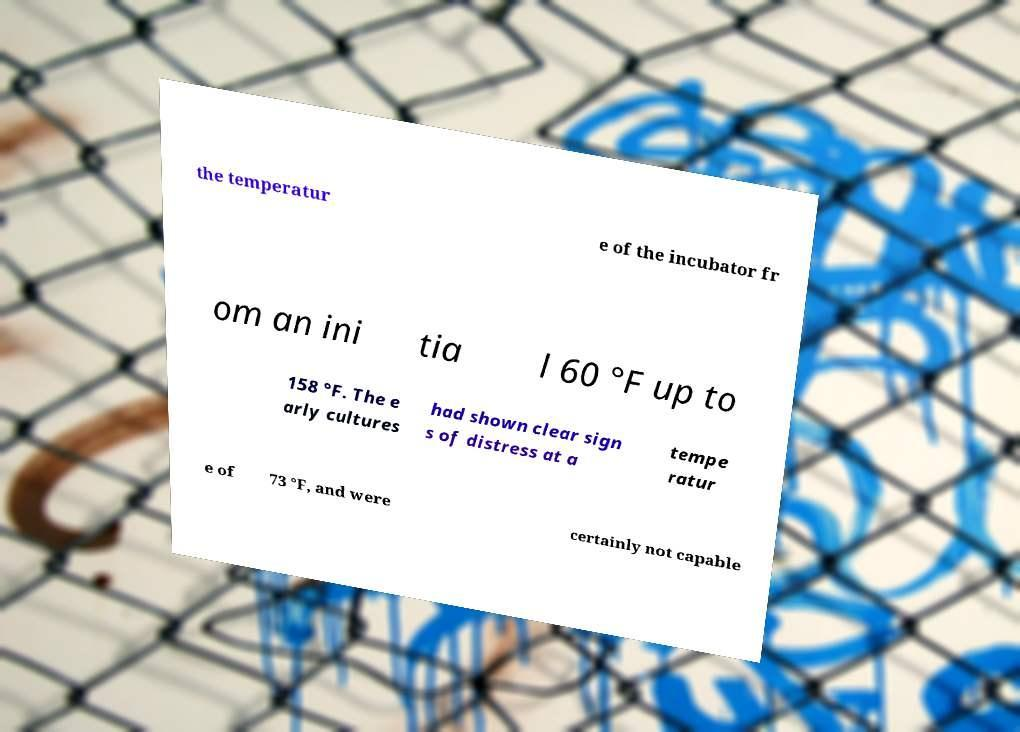Please identify and transcribe the text found in this image. the temperatur e of the incubator fr om an ini tia l 60 °F up to 158 °F. The e arly cultures had shown clear sign s of distress at a tempe ratur e of 73 °F, and were certainly not capable 